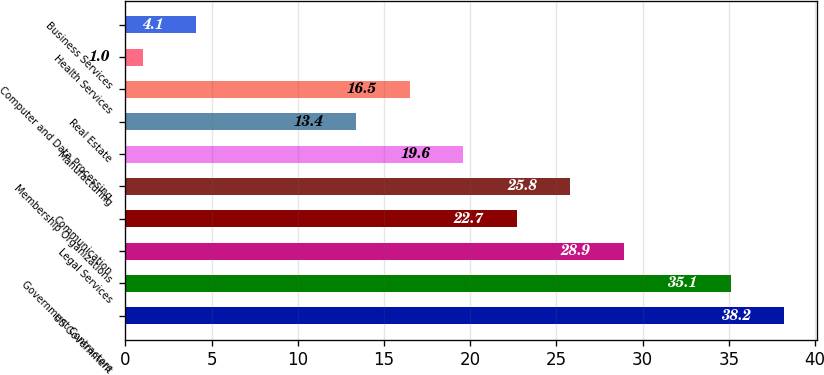Convert chart. <chart><loc_0><loc_0><loc_500><loc_500><bar_chart><fcel>US Government<fcel>Government Contractors<fcel>Legal Services<fcel>Communication<fcel>Membership Organizations<fcel>Manufacturing<fcel>Real Estate<fcel>Computer and Data Processing<fcel>Health Services<fcel>Business Services<nl><fcel>38.2<fcel>35.1<fcel>28.9<fcel>22.7<fcel>25.8<fcel>19.6<fcel>13.4<fcel>16.5<fcel>1<fcel>4.1<nl></chart> 